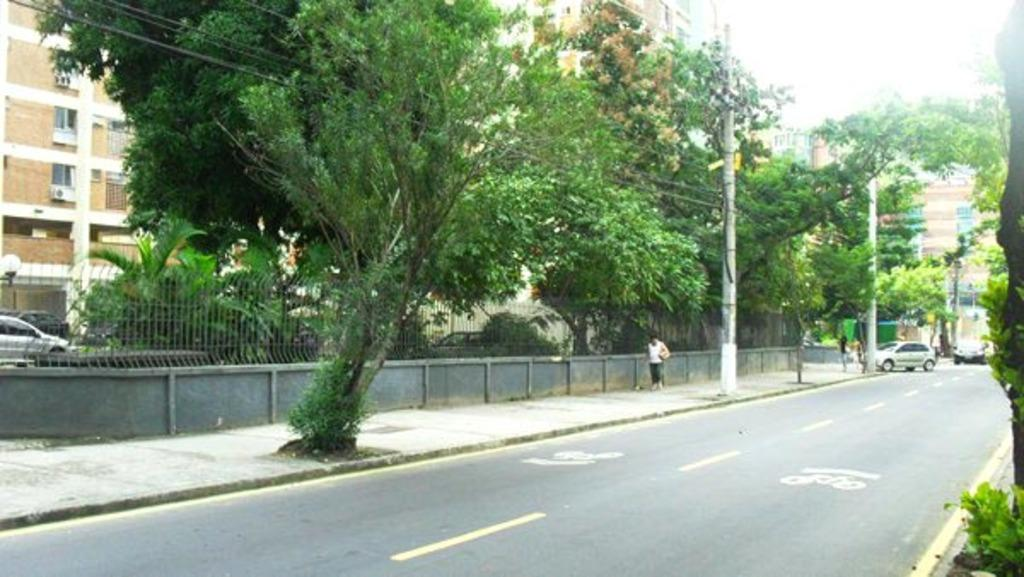What is the main feature of the image? There is a road in the image. What is happening on the road? Cars are present on the road. Are there any people in the image? Yes, there are people in the image. What can be seen in the background of the image? There is a fence, trees, poles, buildings, wires, and the sky visible in the background of the image. Can you see any agreements being signed in the image? There is no indication of any agreements being signed in the image. Is anyone smashing their thumb in the image? There is no thumb-smashing activity depicted in the image. 